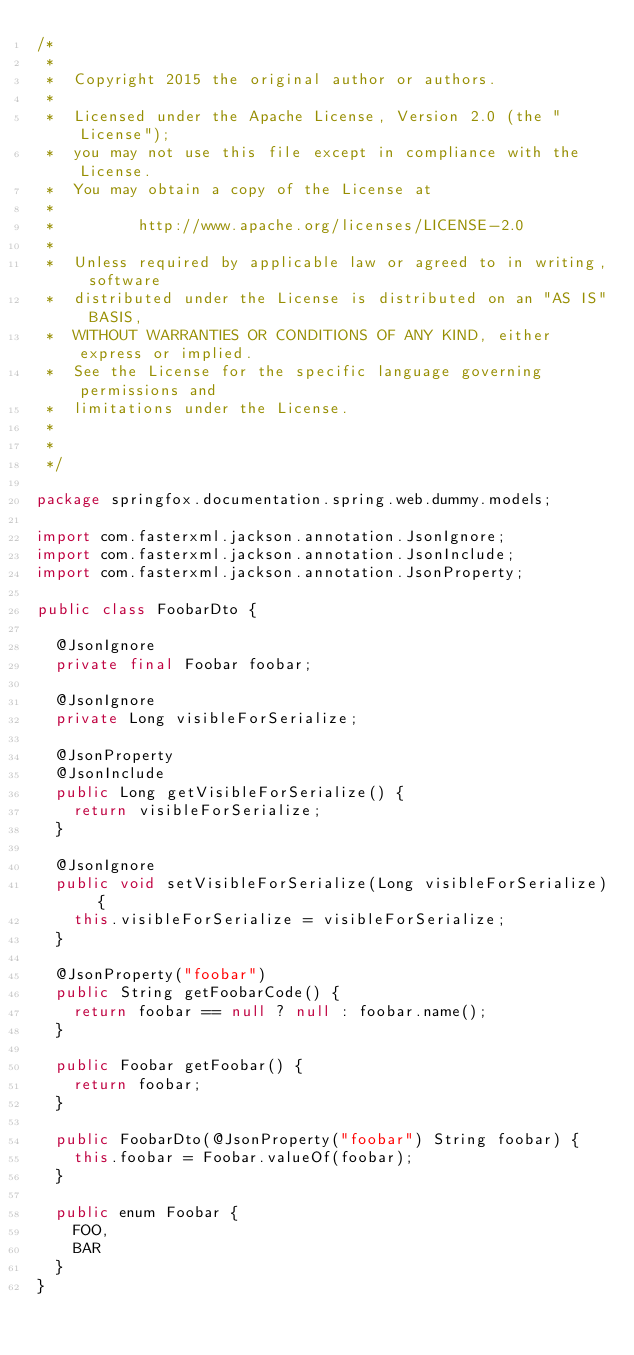Convert code to text. <code><loc_0><loc_0><loc_500><loc_500><_Java_>/*
 *
 *  Copyright 2015 the original author or authors.
 *
 *  Licensed under the Apache License, Version 2.0 (the "License");
 *  you may not use this file except in compliance with the License.
 *  You may obtain a copy of the License at
 *
 *         http://www.apache.org/licenses/LICENSE-2.0
 *
 *  Unless required by applicable law or agreed to in writing, software
 *  distributed under the License is distributed on an "AS IS" BASIS,
 *  WITHOUT WARRANTIES OR CONDITIONS OF ANY KIND, either express or implied.
 *  See the License for the specific language governing permissions and
 *  limitations under the License.
 *
 *
 */

package springfox.documentation.spring.web.dummy.models;

import com.fasterxml.jackson.annotation.JsonIgnore;
import com.fasterxml.jackson.annotation.JsonInclude;
import com.fasterxml.jackson.annotation.JsonProperty;

public class FoobarDto {

  @JsonIgnore
  private final Foobar foobar;

  @JsonIgnore
  private Long visibleForSerialize;

  @JsonProperty
  @JsonInclude
  public Long getVisibleForSerialize() {
    return visibleForSerialize;
  }

  @JsonIgnore
  public void setVisibleForSerialize(Long visibleForSerialize) {
    this.visibleForSerialize = visibleForSerialize;
  }

  @JsonProperty("foobar")
  public String getFoobarCode() {
    return foobar == null ? null : foobar.name();
  }

  public Foobar getFoobar() {
    return foobar;
  }

  public FoobarDto(@JsonProperty("foobar") String foobar) {
    this.foobar = Foobar.valueOf(foobar);
  }

  public enum Foobar {
    FOO,
    BAR
  }
}
</code> 